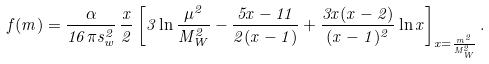Convert formula to latex. <formula><loc_0><loc_0><loc_500><loc_500>f ( m ) = \frac { \alpha } { 1 6 \pi s _ { w } ^ { 2 } } \, \frac { x } { 2 } \left [ 3 \ln \frac { \mu ^ { 2 } } { M _ { W } ^ { 2 } } - \frac { 5 x - 1 1 } { 2 ( x - 1 ) } + \frac { 3 x ( x - 2 ) } { ( x - 1 ) ^ { 2 } } \ln x \right ] _ { x = \frac { m ^ { 2 } } { M _ { W } ^ { 2 } } } .</formula> 